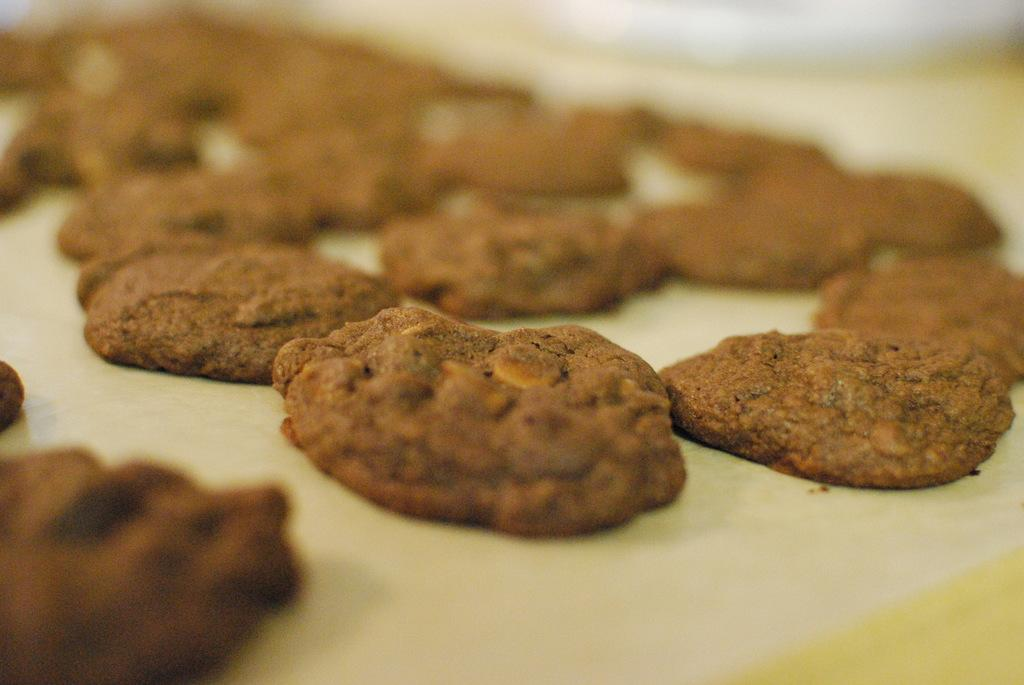What type of food can be seen on the surface in the image? There are cookies on a surface in the image. What can be inferred about the setting or environment from the background of the image? The background of the image appears to be bur. How many hands are visible in the image? There are no hands visible in the image. What type of natural disaster is occurring in the image? There is no indication of a natural disaster, such as an earthquake, in the image. 